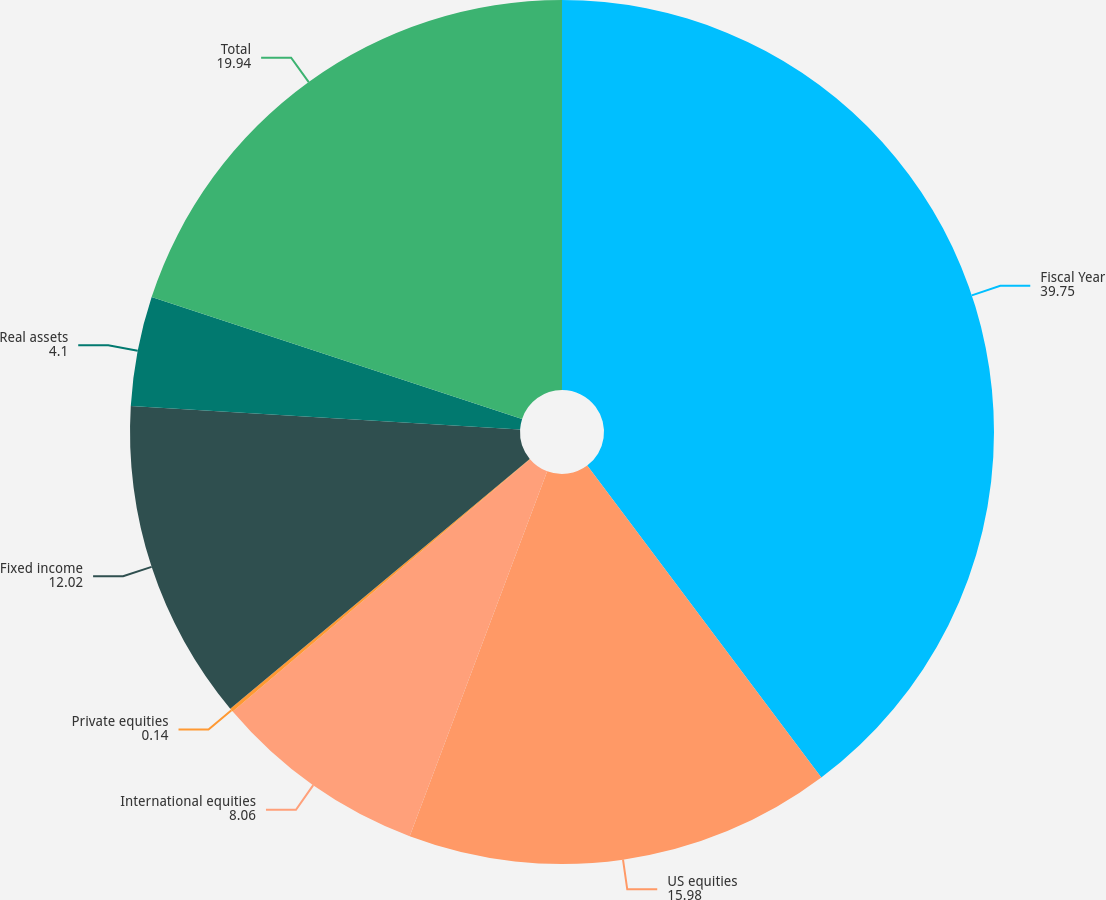<chart> <loc_0><loc_0><loc_500><loc_500><pie_chart><fcel>Fiscal Year<fcel>US equities<fcel>International equities<fcel>Private equities<fcel>Fixed income<fcel>Real assets<fcel>Total<nl><fcel>39.75%<fcel>15.98%<fcel>8.06%<fcel>0.14%<fcel>12.02%<fcel>4.1%<fcel>19.94%<nl></chart> 